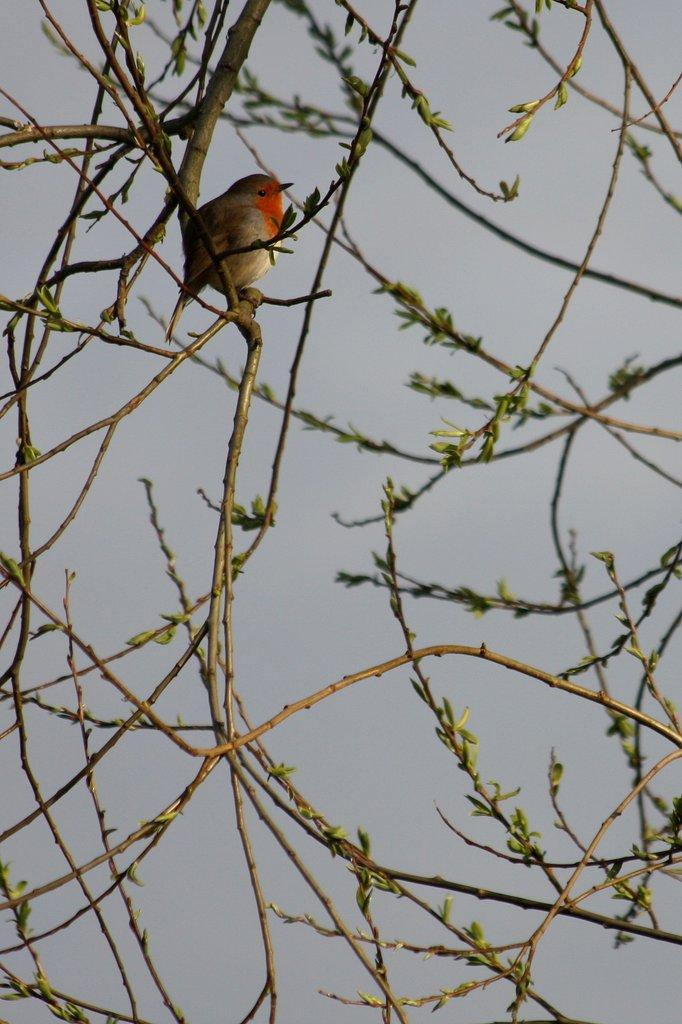What type of animal can be seen in the image? There is a bird in the image. Where is the bird located in the image? The bird is on the branches of a plant. What type of acoustics can be heard from the bird in the image? There is no information about the bird's acoustics in the image, so it cannot be determined. 